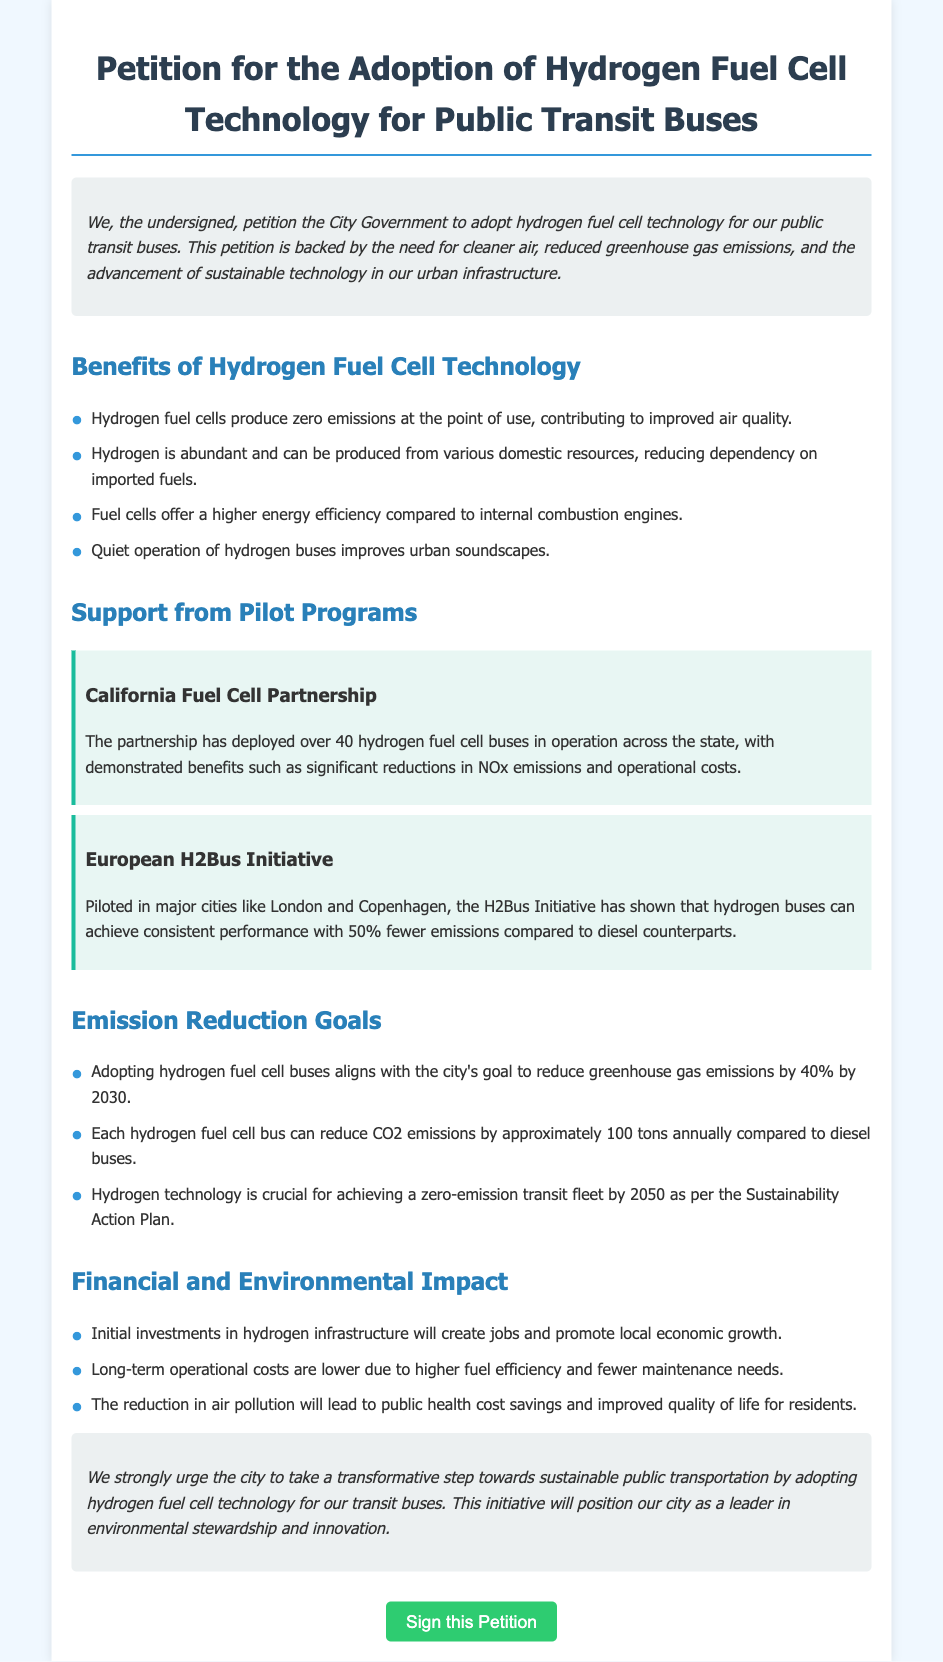What is the title of the petition? The title of the petition is stated prominently at the beginning of the document.
Answer: Petition for the Adoption of Hydrogen Fuel Cell Technology for Public Transit Buses How many hydrogen fuel cell buses are in operation in California? The document mentions an operational figure from the California Fuel Cell Partnership.
Answer: Over 40 hydrogen fuel cell buses What is the expected reduction in greenhouse gas emissions by 2030? The document outlines a specific emission reduction target set by the city.
Answer: 40% What is the annual CO2 emission reduction per hydrogen fuel cell bus? The petition states the environmental impact of each bus in terms of CO2 emissions.
Answer: Approximately 100 tons Which initiative piloted hydrogen buses in London and Copenhagen? The document identifies a specific initiative related to the implementation of hydrogen buses.
Answer: European H2Bus Initiative What is one benefit of hydrogen fuel cell technology for air quality? The document describes a specific benefit that relates to pollution and air quality.
Answer: Zero emissions at the point of use What are the long-term operational cost benefits associated with hydrogen buses? The document suggests advantages concerning the costs of operation and maintenance of hydrogen buses.
Answer: Lower due to higher fuel efficiency and fewer maintenance needs What is the conclusion of the petition? The conclusion reiterates the call to action for the city government, found at the end of the document.
Answer: A transformative step towards sustainable public transportation What is the estimated public health impact of adopting hydrogen technology? The petition explains the implications of better air quality for community health expenses.
Answer: Public health cost savings and improved quality of life for residents 